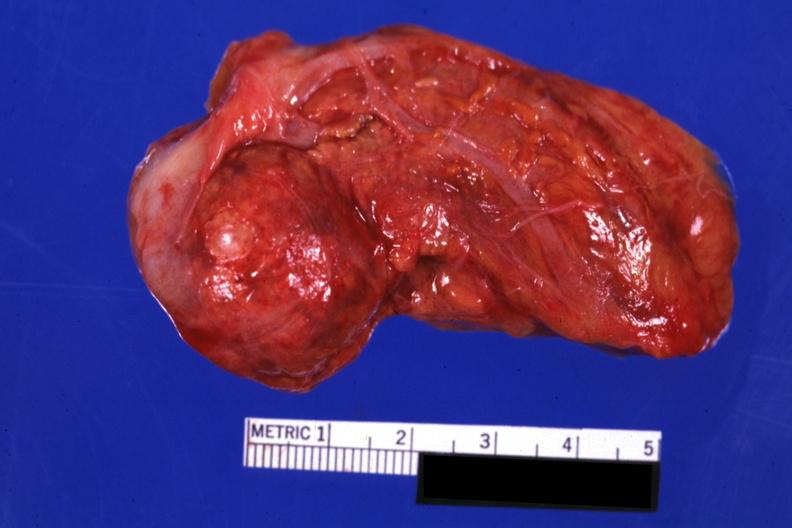s endocrine present?
Answer the question using a single word or phrase. Yes 